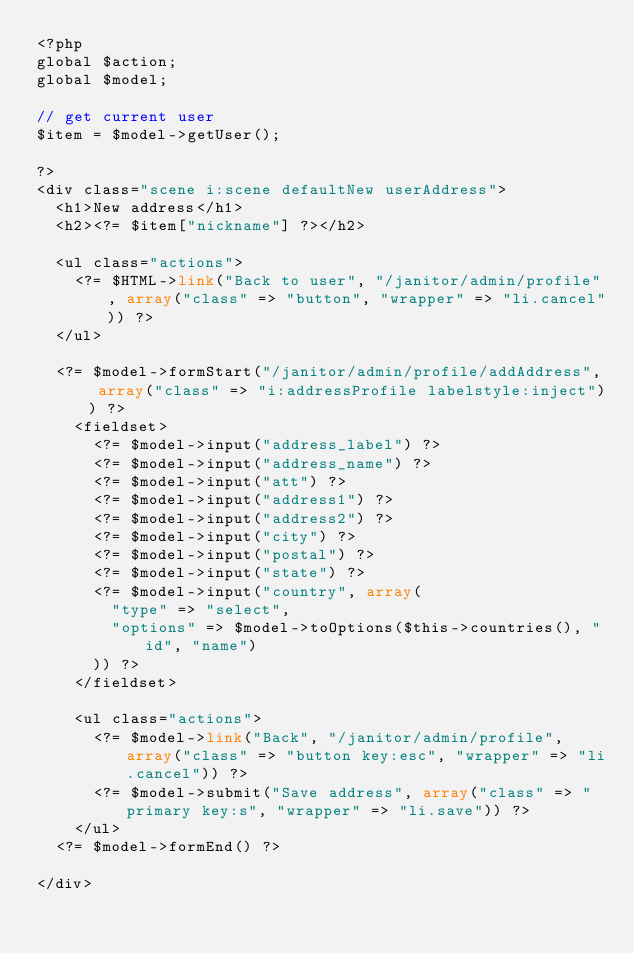Convert code to text. <code><loc_0><loc_0><loc_500><loc_500><_PHP_><?php
global $action;
global $model;

// get current user
$item = $model->getUser();

?>
<div class="scene i:scene defaultNew userAddress">
	<h1>New address</h1>
	<h2><?= $item["nickname"] ?></h2>

	<ul class="actions">
		<?= $HTML->link("Back to user", "/janitor/admin/profile", array("class" => "button", "wrapper" => "li.cancel")) ?>
	</ul>

	<?= $model->formStart("/janitor/admin/profile/addAddress", array("class" => "i:addressProfile labelstyle:inject")) ?>
		<fieldset>
			<?= $model->input("address_label") ?>
			<?= $model->input("address_name") ?>
			<?= $model->input("att") ?>
			<?= $model->input("address1") ?>
			<?= $model->input("address2") ?>
			<?= $model->input("city") ?>
			<?= $model->input("postal") ?>
			<?= $model->input("state") ?>
			<?= $model->input("country", array(
				"type" => "select",
				"options" => $model->toOptions($this->countries(), "id", "name")
			)) ?>
		</fieldset>

		<ul class="actions">
			<?= $model->link("Back", "/janitor/admin/profile", array("class" => "button key:esc", "wrapper" => "li.cancel")) ?>
			<?= $model->submit("Save address", array("class" => "primary key:s", "wrapper" => "li.save")) ?>
		</ul>
	<?= $model->formEnd() ?>

</div></code> 